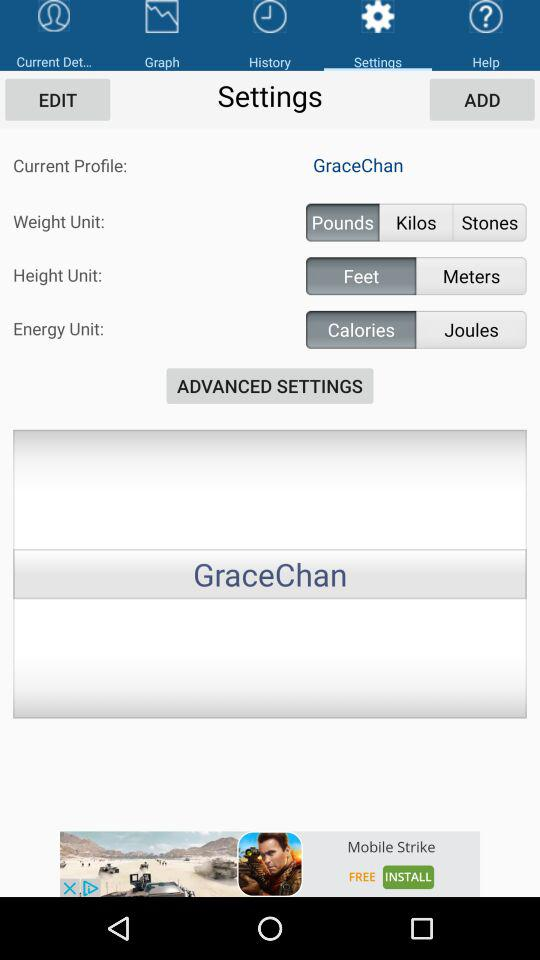What is the unit of weight? The unit of weight is pounds. 